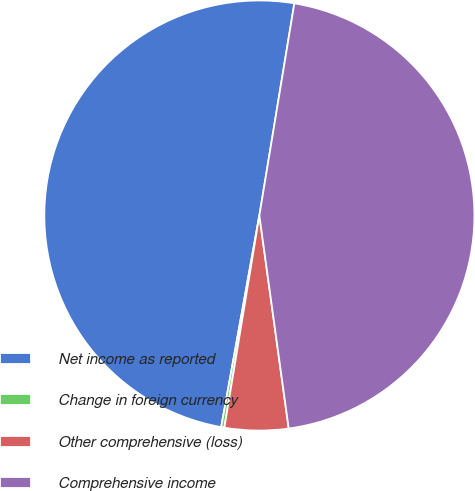Convert chart to OTSL. <chart><loc_0><loc_0><loc_500><loc_500><pie_chart><fcel>Net income as reported<fcel>Change in foreign currency<fcel>Other comprehensive (loss)<fcel>Comprehensive income<nl><fcel>49.76%<fcel>0.24%<fcel>4.78%<fcel>45.22%<nl></chart> 